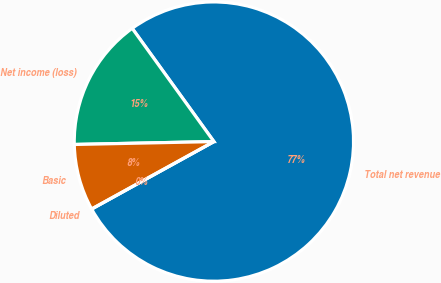Convert chart to OTSL. <chart><loc_0><loc_0><loc_500><loc_500><pie_chart><fcel>Total net revenue<fcel>Net income (loss)<fcel>Basic<fcel>Diluted<nl><fcel>76.92%<fcel>15.38%<fcel>7.69%<fcel>0.0%<nl></chart> 